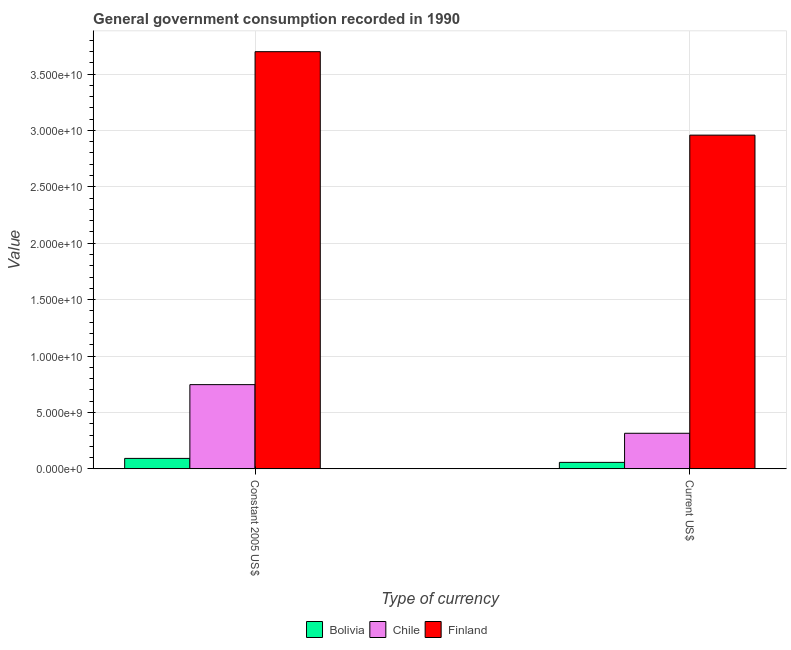How many different coloured bars are there?
Offer a very short reply. 3. Are the number of bars on each tick of the X-axis equal?
Keep it short and to the point. Yes. What is the label of the 1st group of bars from the left?
Provide a short and direct response. Constant 2005 US$. What is the value consumed in constant 2005 us$ in Finland?
Offer a very short reply. 3.70e+1. Across all countries, what is the maximum value consumed in current us$?
Provide a succinct answer. 2.96e+1. Across all countries, what is the minimum value consumed in constant 2005 us$?
Offer a very short reply. 9.26e+08. What is the total value consumed in constant 2005 us$ in the graph?
Make the answer very short. 4.54e+1. What is the difference between the value consumed in current us$ in Chile and that in Finland?
Give a very brief answer. -2.64e+1. What is the difference between the value consumed in constant 2005 us$ in Finland and the value consumed in current us$ in Bolivia?
Your answer should be compact. 3.64e+1. What is the average value consumed in current us$ per country?
Provide a succinct answer. 1.11e+1. What is the difference between the value consumed in current us$ and value consumed in constant 2005 us$ in Chile?
Make the answer very short. -4.31e+09. In how many countries, is the value consumed in constant 2005 us$ greater than 37000000000 ?
Provide a short and direct response. 0. What is the ratio of the value consumed in current us$ in Bolivia to that in Chile?
Provide a succinct answer. 0.18. In how many countries, is the value consumed in current us$ greater than the average value consumed in current us$ taken over all countries?
Your answer should be very brief. 1. How many bars are there?
Provide a short and direct response. 6. Are all the bars in the graph horizontal?
Keep it short and to the point. No. How many countries are there in the graph?
Give a very brief answer. 3. What is the difference between two consecutive major ticks on the Y-axis?
Offer a very short reply. 5.00e+09. Does the graph contain grids?
Make the answer very short. Yes. Where does the legend appear in the graph?
Make the answer very short. Bottom center. How many legend labels are there?
Provide a short and direct response. 3. What is the title of the graph?
Keep it short and to the point. General government consumption recorded in 1990. Does "Antigua and Barbuda" appear as one of the legend labels in the graph?
Provide a succinct answer. No. What is the label or title of the X-axis?
Your answer should be compact. Type of currency. What is the label or title of the Y-axis?
Offer a very short reply. Value. What is the Value in Bolivia in Constant 2005 US$?
Make the answer very short. 9.26e+08. What is the Value in Chile in Constant 2005 US$?
Provide a short and direct response. 7.46e+09. What is the Value of Finland in Constant 2005 US$?
Offer a very short reply. 3.70e+1. What is the Value in Bolivia in Current US$?
Offer a terse response. 5.72e+08. What is the Value of Chile in Current US$?
Offer a terse response. 3.15e+09. What is the Value of Finland in Current US$?
Provide a succinct answer. 2.96e+1. Across all Type of currency, what is the maximum Value of Bolivia?
Offer a very short reply. 9.26e+08. Across all Type of currency, what is the maximum Value in Chile?
Offer a very short reply. 7.46e+09. Across all Type of currency, what is the maximum Value of Finland?
Give a very brief answer. 3.70e+1. Across all Type of currency, what is the minimum Value in Bolivia?
Ensure brevity in your answer.  5.72e+08. Across all Type of currency, what is the minimum Value in Chile?
Offer a terse response. 3.15e+09. Across all Type of currency, what is the minimum Value of Finland?
Offer a very short reply. 2.96e+1. What is the total Value of Bolivia in the graph?
Provide a succinct answer. 1.50e+09. What is the total Value in Chile in the graph?
Keep it short and to the point. 1.06e+1. What is the total Value of Finland in the graph?
Offer a terse response. 6.66e+1. What is the difference between the Value in Bolivia in Constant 2005 US$ and that in Current US$?
Your answer should be compact. 3.54e+08. What is the difference between the Value in Chile in Constant 2005 US$ and that in Current US$?
Provide a short and direct response. 4.31e+09. What is the difference between the Value of Finland in Constant 2005 US$ and that in Current US$?
Offer a very short reply. 7.40e+09. What is the difference between the Value of Bolivia in Constant 2005 US$ and the Value of Chile in Current US$?
Provide a succinct answer. -2.23e+09. What is the difference between the Value of Bolivia in Constant 2005 US$ and the Value of Finland in Current US$?
Offer a very short reply. -2.87e+1. What is the difference between the Value of Chile in Constant 2005 US$ and the Value of Finland in Current US$?
Offer a terse response. -2.21e+1. What is the average Value of Bolivia per Type of currency?
Offer a terse response. 7.49e+08. What is the average Value of Chile per Type of currency?
Give a very brief answer. 5.31e+09. What is the average Value in Finland per Type of currency?
Your answer should be very brief. 3.33e+1. What is the difference between the Value of Bolivia and Value of Chile in Constant 2005 US$?
Offer a very short reply. -6.54e+09. What is the difference between the Value of Bolivia and Value of Finland in Constant 2005 US$?
Keep it short and to the point. -3.61e+1. What is the difference between the Value of Chile and Value of Finland in Constant 2005 US$?
Offer a terse response. -2.95e+1. What is the difference between the Value in Bolivia and Value in Chile in Current US$?
Offer a very short reply. -2.58e+09. What is the difference between the Value in Bolivia and Value in Finland in Current US$?
Your answer should be compact. -2.90e+1. What is the difference between the Value in Chile and Value in Finland in Current US$?
Give a very brief answer. -2.64e+1. What is the ratio of the Value in Bolivia in Constant 2005 US$ to that in Current US$?
Keep it short and to the point. 1.62. What is the ratio of the Value of Chile in Constant 2005 US$ to that in Current US$?
Keep it short and to the point. 2.37. What is the ratio of the Value of Finland in Constant 2005 US$ to that in Current US$?
Your answer should be very brief. 1.25. What is the difference between the highest and the second highest Value in Bolivia?
Your response must be concise. 3.54e+08. What is the difference between the highest and the second highest Value of Chile?
Offer a terse response. 4.31e+09. What is the difference between the highest and the second highest Value in Finland?
Provide a succinct answer. 7.40e+09. What is the difference between the highest and the lowest Value of Bolivia?
Ensure brevity in your answer.  3.54e+08. What is the difference between the highest and the lowest Value of Chile?
Ensure brevity in your answer.  4.31e+09. What is the difference between the highest and the lowest Value in Finland?
Offer a very short reply. 7.40e+09. 